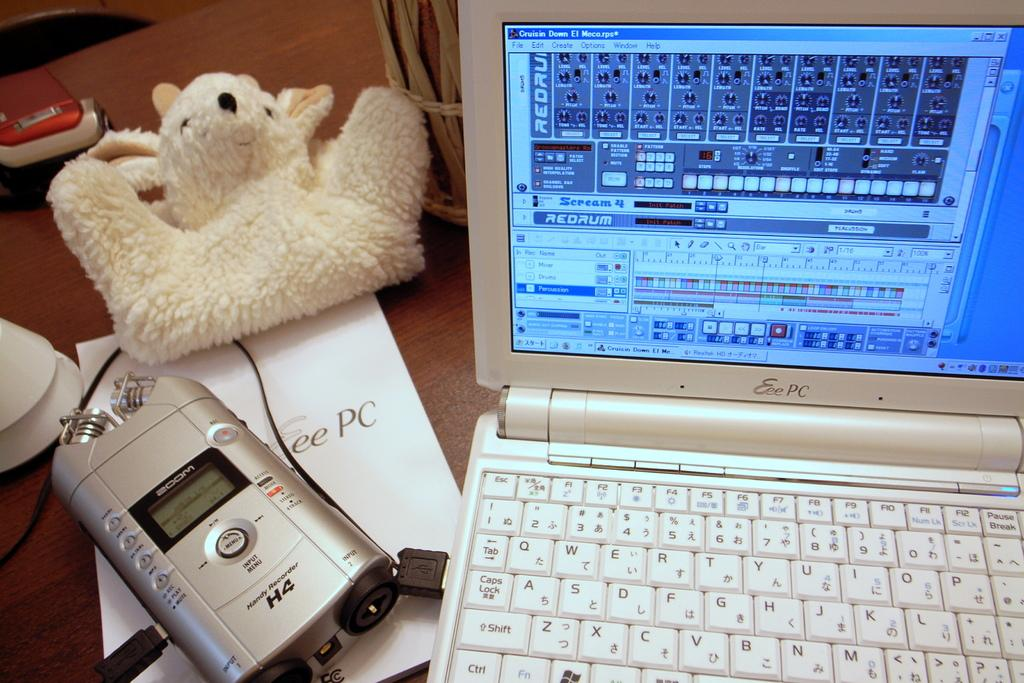<image>
Provide a brief description of the given image. A laptop computer with Scream 4 Redrum on the screen. 